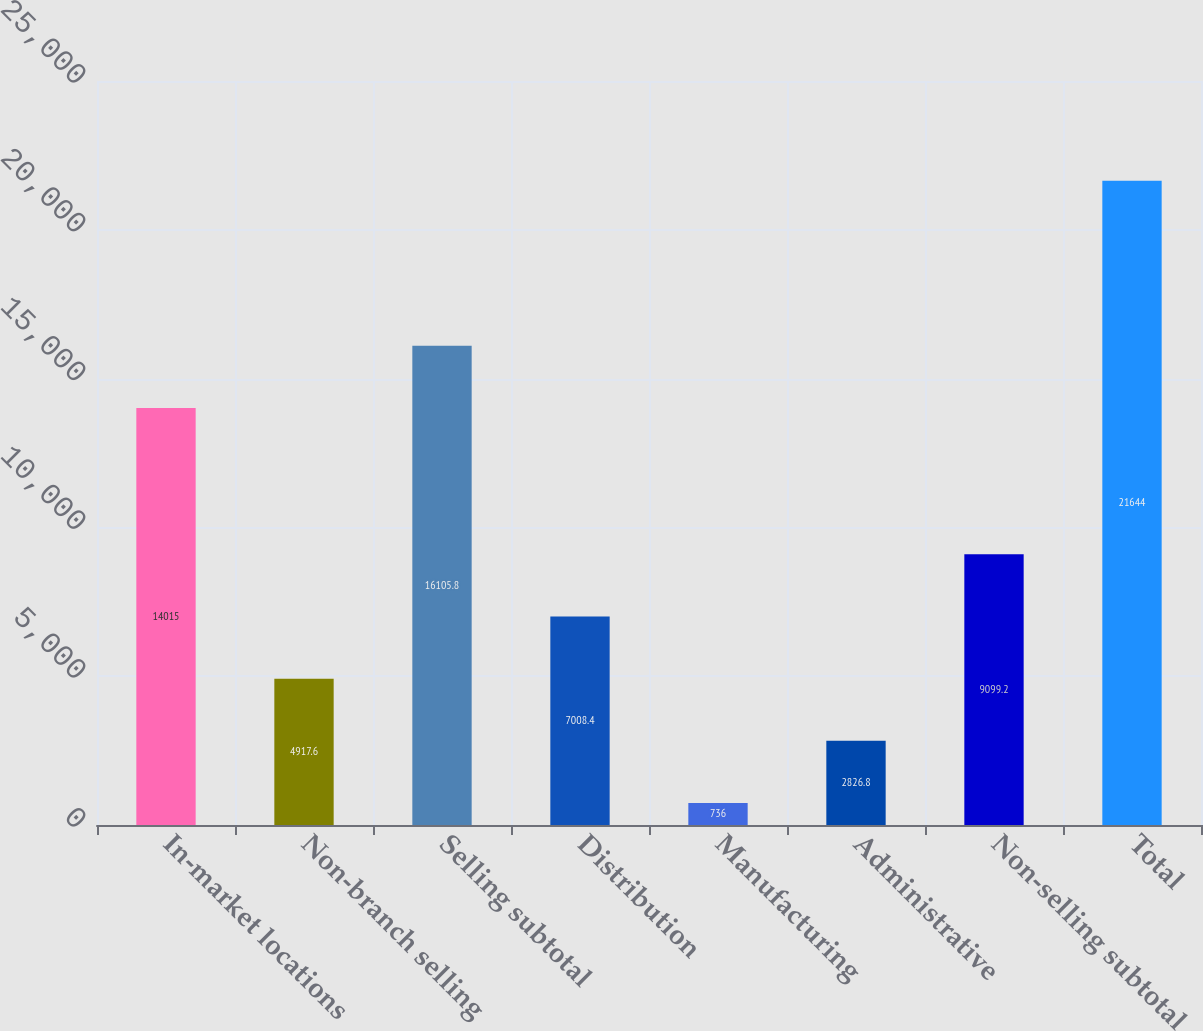<chart> <loc_0><loc_0><loc_500><loc_500><bar_chart><fcel>In-market locations<fcel>Non-branch selling<fcel>Selling subtotal<fcel>Distribution<fcel>Manufacturing<fcel>Administrative<fcel>Non-selling subtotal<fcel>Total<nl><fcel>14015<fcel>4917.6<fcel>16105.8<fcel>7008.4<fcel>736<fcel>2826.8<fcel>9099.2<fcel>21644<nl></chart> 